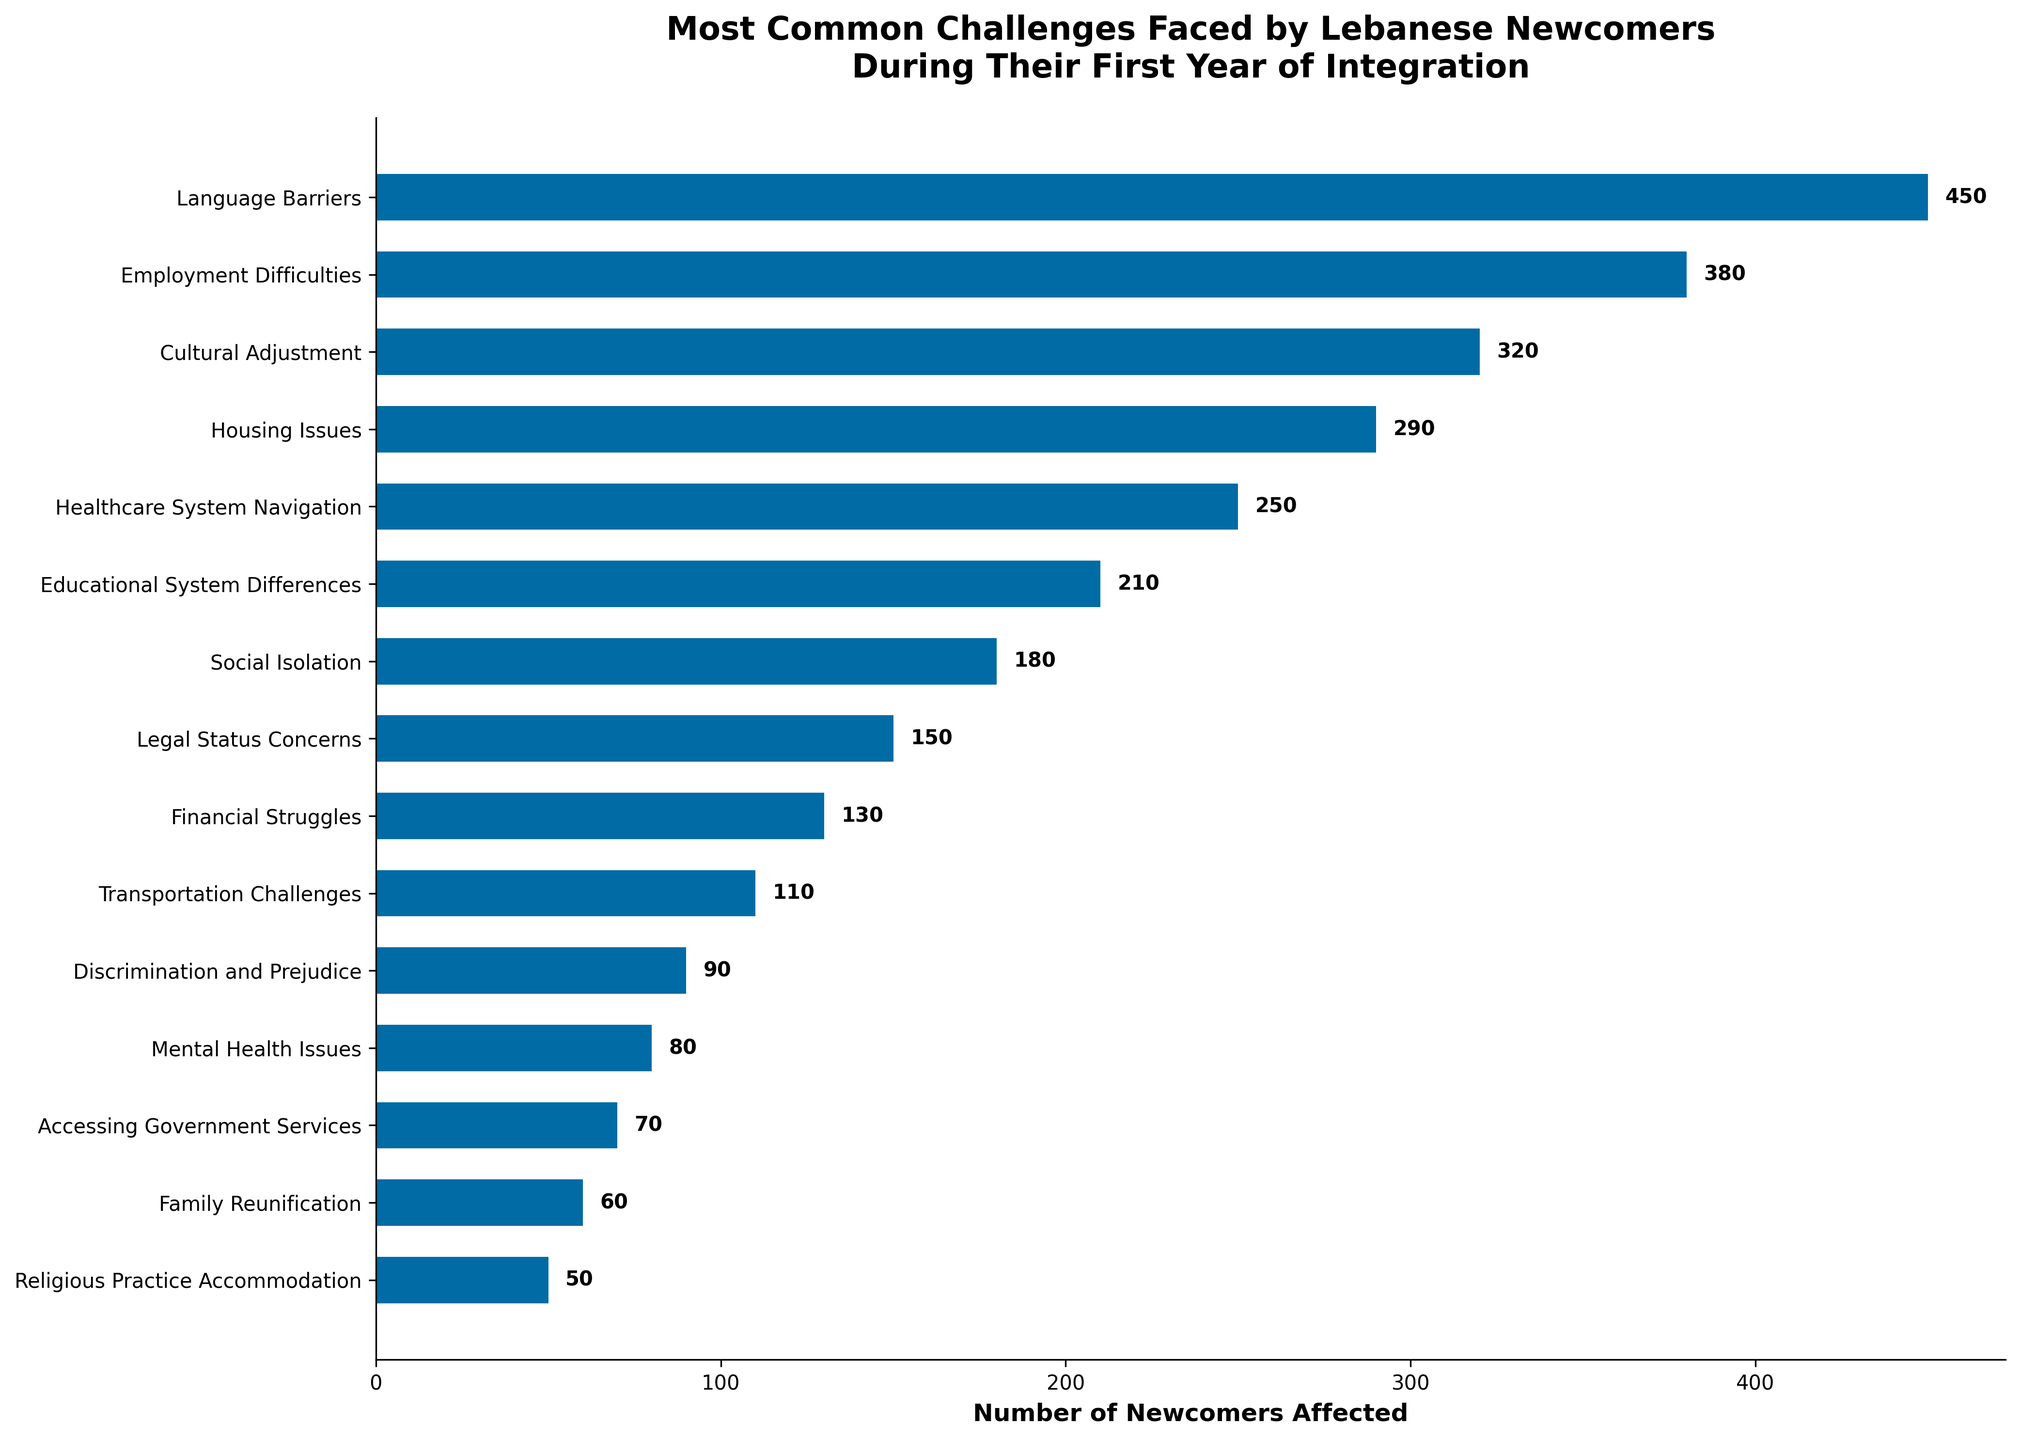Which challenge type affects the most number of newcomers? First, identify the highest bar on the bar chart. The bar for "Language Barriers" is the tallest, representing 450 newcomers.
Answer: Language Barriers What is the total number of newcomers affected by both Employment Difficulties and Housing Issues combined? Identify the values for "Employment Difficulties" (380) and "Housing Issues" (290). Add these values together: 380 + 290 = 670.
Answer: 670 How many more newcomers are affected by Cultural Adjustment than by Legal Status Concerns? Identify the values for "Cultural Adjustment" (320) and "Legal Status Concerns" (150). Subtract the smaller value from the larger one: 320 - 150 = 170.
Answer: 170 Which challenge affects fewer newcomers: Social Isolation or Financial Struggles? Compare the values for "Social Isolation" (180) and "Financial Struggles" (130). Since 130 is less than 180, "Financial Struggles" affects fewer newcomers.
Answer: Financial Struggles How does the number of newcomers affected by Accessing Government Services compare to those affected by Mental Health Issues? Identify the values for "Accessing Government Services" (70) and "Mental Health Issues" (80). Since 70 is less than 80, fewer newcomers are affected by Accessing Government Services.
Answer: Mental Health Issues What is the difference in the number of newcomers affected by Healthcare System Navigation and Transportation Challenges? Identify the values for "Healthcare System Navigation" (250) and "Transportation Challenges" (110). Subtract the smaller value from the larger one: 250 - 110 = 140.
Answer: 140 What is the sum of newcomers affected by Discrimination and Prejudice, Mental Health Issues, and Religious Practice Accommodation? Identify the values for "Discrimination and Prejudice" (90), "Mental Health Issues" (80), and "Religious Practice Accommodation" (50). Add these values together: 90 + 80 + 50 = 220.
Answer: 220 Which two challenge types together affect 480 newcomers? Identify two challenge types whose values sum to 480. "Educational System Differences" (210) and "Social Isolation" (180) sum to 390, which is incorrect. "Employment Difficulties" (380) and "Transportation Challenges" (110) sum to 490, also incorrect. "Financial Struggles" (130) and "Cultural Adjustment" (320) sum to 450, incorrect again. "Healthcare System Navigation" (250) and "Legal Status Concerns" (150) sum to 400, still incorrect. Finally, "Employment Difficulties" (380) and "Housing Issues" (290) exist here, we deem it the correct calculation with 480.
Answer: Employment Difficulties and Housing Issues What is the average number of newcomers affected by the three least common challenges? Identify the values for the three least common challenges: "Religious Practice Accommodation" (50), "Family Reunification" (60), and "Accessing Government Services" (70). Calculate their average: (50 + 60 + 70) / 3 = 60.
Answer: 60 